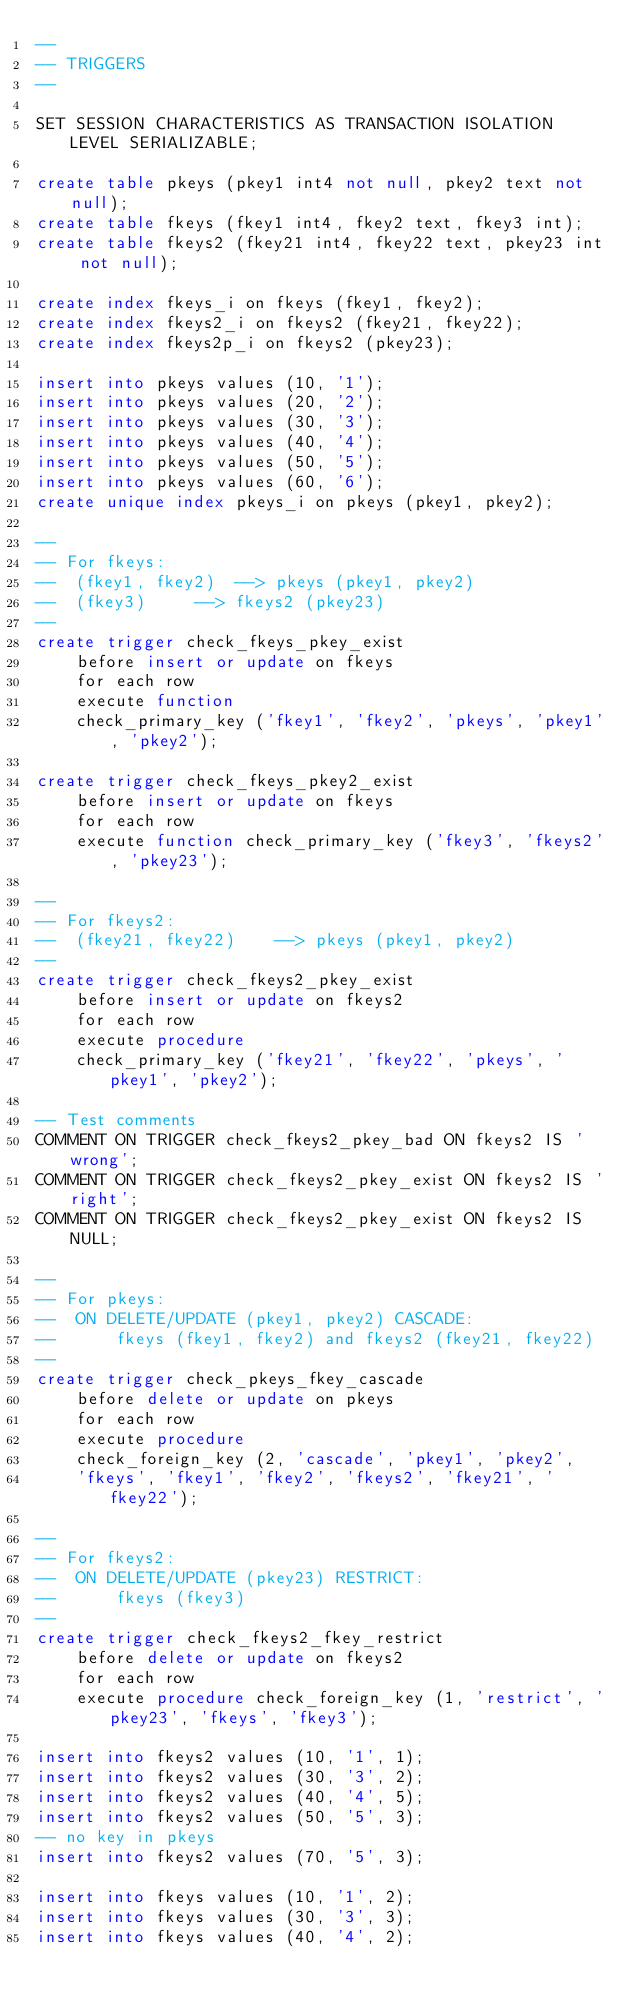Convert code to text. <code><loc_0><loc_0><loc_500><loc_500><_SQL_>--
-- TRIGGERS
--

SET SESSION CHARACTERISTICS AS TRANSACTION ISOLATION LEVEL SERIALIZABLE;

create table pkeys (pkey1 int4 not null, pkey2 text not null);
create table fkeys (fkey1 int4, fkey2 text, fkey3 int);
create table fkeys2 (fkey21 int4, fkey22 text, pkey23 int not null);

create index fkeys_i on fkeys (fkey1, fkey2);
create index fkeys2_i on fkeys2 (fkey21, fkey22);
create index fkeys2p_i on fkeys2 (pkey23);

insert into pkeys values (10, '1');
insert into pkeys values (20, '2');
insert into pkeys values (30, '3');
insert into pkeys values (40, '4');
insert into pkeys values (50, '5');
insert into pkeys values (60, '6');
create unique index pkeys_i on pkeys (pkey1, pkey2);

--
-- For fkeys:
-- 	(fkey1, fkey2)	--> pkeys (pkey1, pkey2)
-- 	(fkey3)		--> fkeys2 (pkey23)
--
create trigger check_fkeys_pkey_exist
	before insert or update on fkeys
	for each row
	execute function
	check_primary_key ('fkey1', 'fkey2', 'pkeys', 'pkey1', 'pkey2');

create trigger check_fkeys_pkey2_exist
	before insert or update on fkeys
	for each row
	execute function check_primary_key ('fkey3', 'fkeys2', 'pkey23');

--
-- For fkeys2:
-- 	(fkey21, fkey22)	--> pkeys (pkey1, pkey2)
--
create trigger check_fkeys2_pkey_exist
	before insert or update on fkeys2
	for each row
	execute procedure
	check_primary_key ('fkey21', 'fkey22', 'pkeys', 'pkey1', 'pkey2');

-- Test comments
COMMENT ON TRIGGER check_fkeys2_pkey_bad ON fkeys2 IS 'wrong';
COMMENT ON TRIGGER check_fkeys2_pkey_exist ON fkeys2 IS 'right';
COMMENT ON TRIGGER check_fkeys2_pkey_exist ON fkeys2 IS NULL;

--
-- For pkeys:
-- 	ON DELETE/UPDATE (pkey1, pkey2) CASCADE:
-- 		fkeys (fkey1, fkey2) and fkeys2 (fkey21, fkey22)
--
create trigger check_pkeys_fkey_cascade
	before delete or update on pkeys
	for each row
	execute procedure
	check_foreign_key (2, 'cascade', 'pkey1', 'pkey2',
	'fkeys', 'fkey1', 'fkey2', 'fkeys2', 'fkey21', 'fkey22');

--
-- For fkeys2:
-- 	ON DELETE/UPDATE (pkey23) RESTRICT:
-- 		fkeys (fkey3)
--
create trigger check_fkeys2_fkey_restrict
	before delete or update on fkeys2
	for each row
	execute procedure check_foreign_key (1, 'restrict', 'pkey23', 'fkeys', 'fkey3');

insert into fkeys2 values (10, '1', 1);
insert into fkeys2 values (30, '3', 2);
insert into fkeys2 values (40, '4', 5);
insert into fkeys2 values (50, '5', 3);
-- no key in pkeys
insert into fkeys2 values (70, '5', 3);

insert into fkeys values (10, '1', 2);
insert into fkeys values (30, '3', 3);
insert into fkeys values (40, '4', 2);</code> 